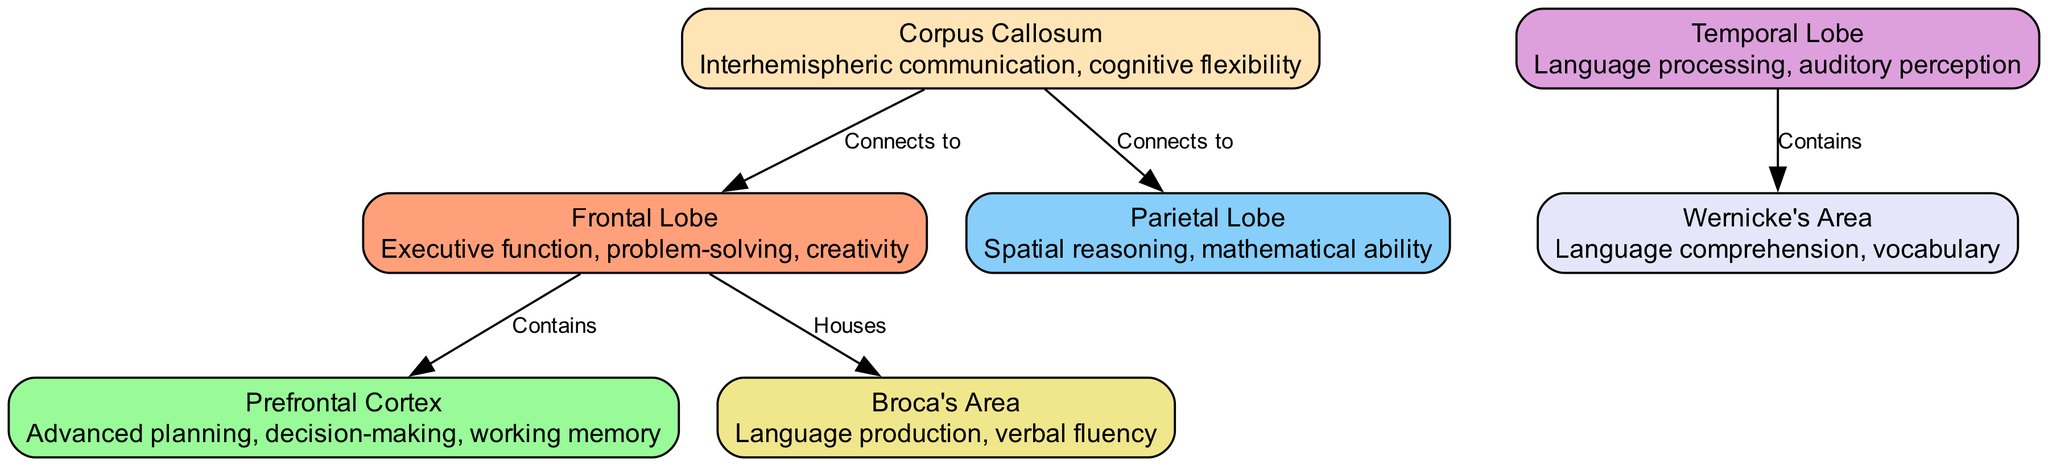What are the cognitive functions associated with the Frontal Lobe? The diagram describes the Frontal Lobe as responsible for executive function, problem-solving, and creativity. This is stated directly in the node for the Frontal Lobe.
Answer: Executive function, problem-solving, creativity Which area connects the Frontal Lobe and Parietal Lobe? According to the edges in the diagram, the Corpus Callosum connects the Frontal Lobe to the Parietal Lobe. This can be seen from the edge labeled "Connects to."
Answer: Corpus Callosum How many nodes are present in the diagram? The total number of nodes listed in the diagram is seven, representing different areas of the brain. This can be counted directly from the nodes section.
Answer: 7 What is the role of Broca's Area? The diagram indicates that Broca's Area is associated with language production and verbal fluency, which is stated directly in its node description.
Answer: Language production, verbal fluency Which lobe is responsible for spatial reasoning? The Parietal Lobe is specifically labeled for spatial reasoning and mathematical ability in its description on the diagram. This can be found in the node for Parietal Lobe.
Answer: Parietal Lobe What function is shared between Wernicke's Area and the Temporal Lobe? The diagram notes that Wernicke's Area is involved in language comprehension and vocabulary, which is a specific function associated with the Temporal Lobe as per the connection indicated in the nodes.
Answer: Language comprehension, vocabulary How many edges are connecting the Corpus Callosum? The diagram shows two edges coming out of the Corpus Callosum, connecting it to both the Frontal Lobe and the Parietal Lobe. Counting the edges linked to this node confirms this.
Answer: 2 What cognitive ability does the Prefrontal Cortex predominantly enhance? The node description for the Prefrontal Cortex highlights advanced planning, decision-making, and working memory as its primary functions. This is directly stated in the node's description.
Answer: Advanced planning, decision-making, working memory 